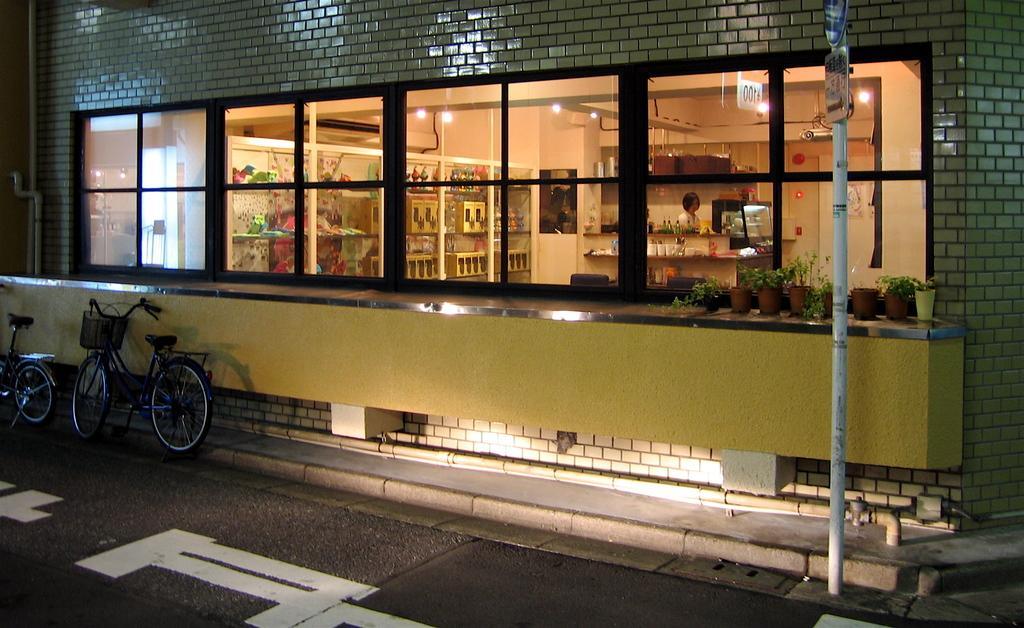Please provide a concise description of this image. In this in the center there is one building, and in in that building there is one person, toys,cupboard, lights and some other objects. And on the left side there are two cycles, at the bottom there is a road and on the right side there is one pole. 